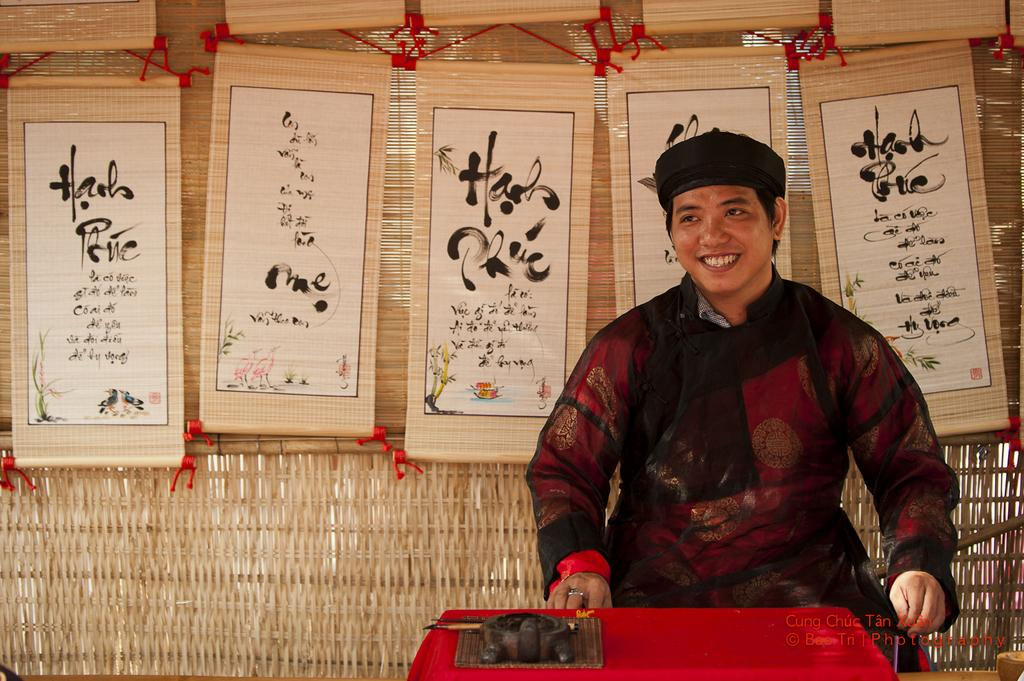Who is present in the image? There is a person in the image. What is the person doing in the image? The person is smiling. What can be seen in the background of the image? There are scroll cards in the background. What is located in the front of the image? There is a table in the front of the image. What type of underwear is the person wearing in the image? There is no information about the person's underwear in the image, so it cannot be determined. 